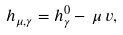Convert formula to latex. <formula><loc_0><loc_0><loc_500><loc_500>h _ { \mu , \gamma } = h ^ { 0 } _ { \gamma } - \, \mu \, v , \\</formula> 